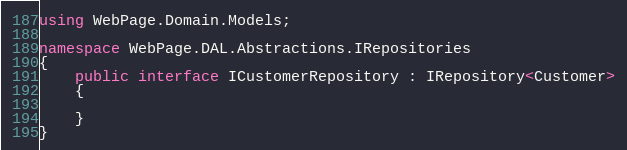Convert code to text. <code><loc_0><loc_0><loc_500><loc_500><_C#_>using WebPage.Domain.Models;

namespace WebPage.DAL.Abstractions.IRepositories
{
    public interface ICustomerRepository : IRepository<Customer>
    {
        
    }
}</code> 